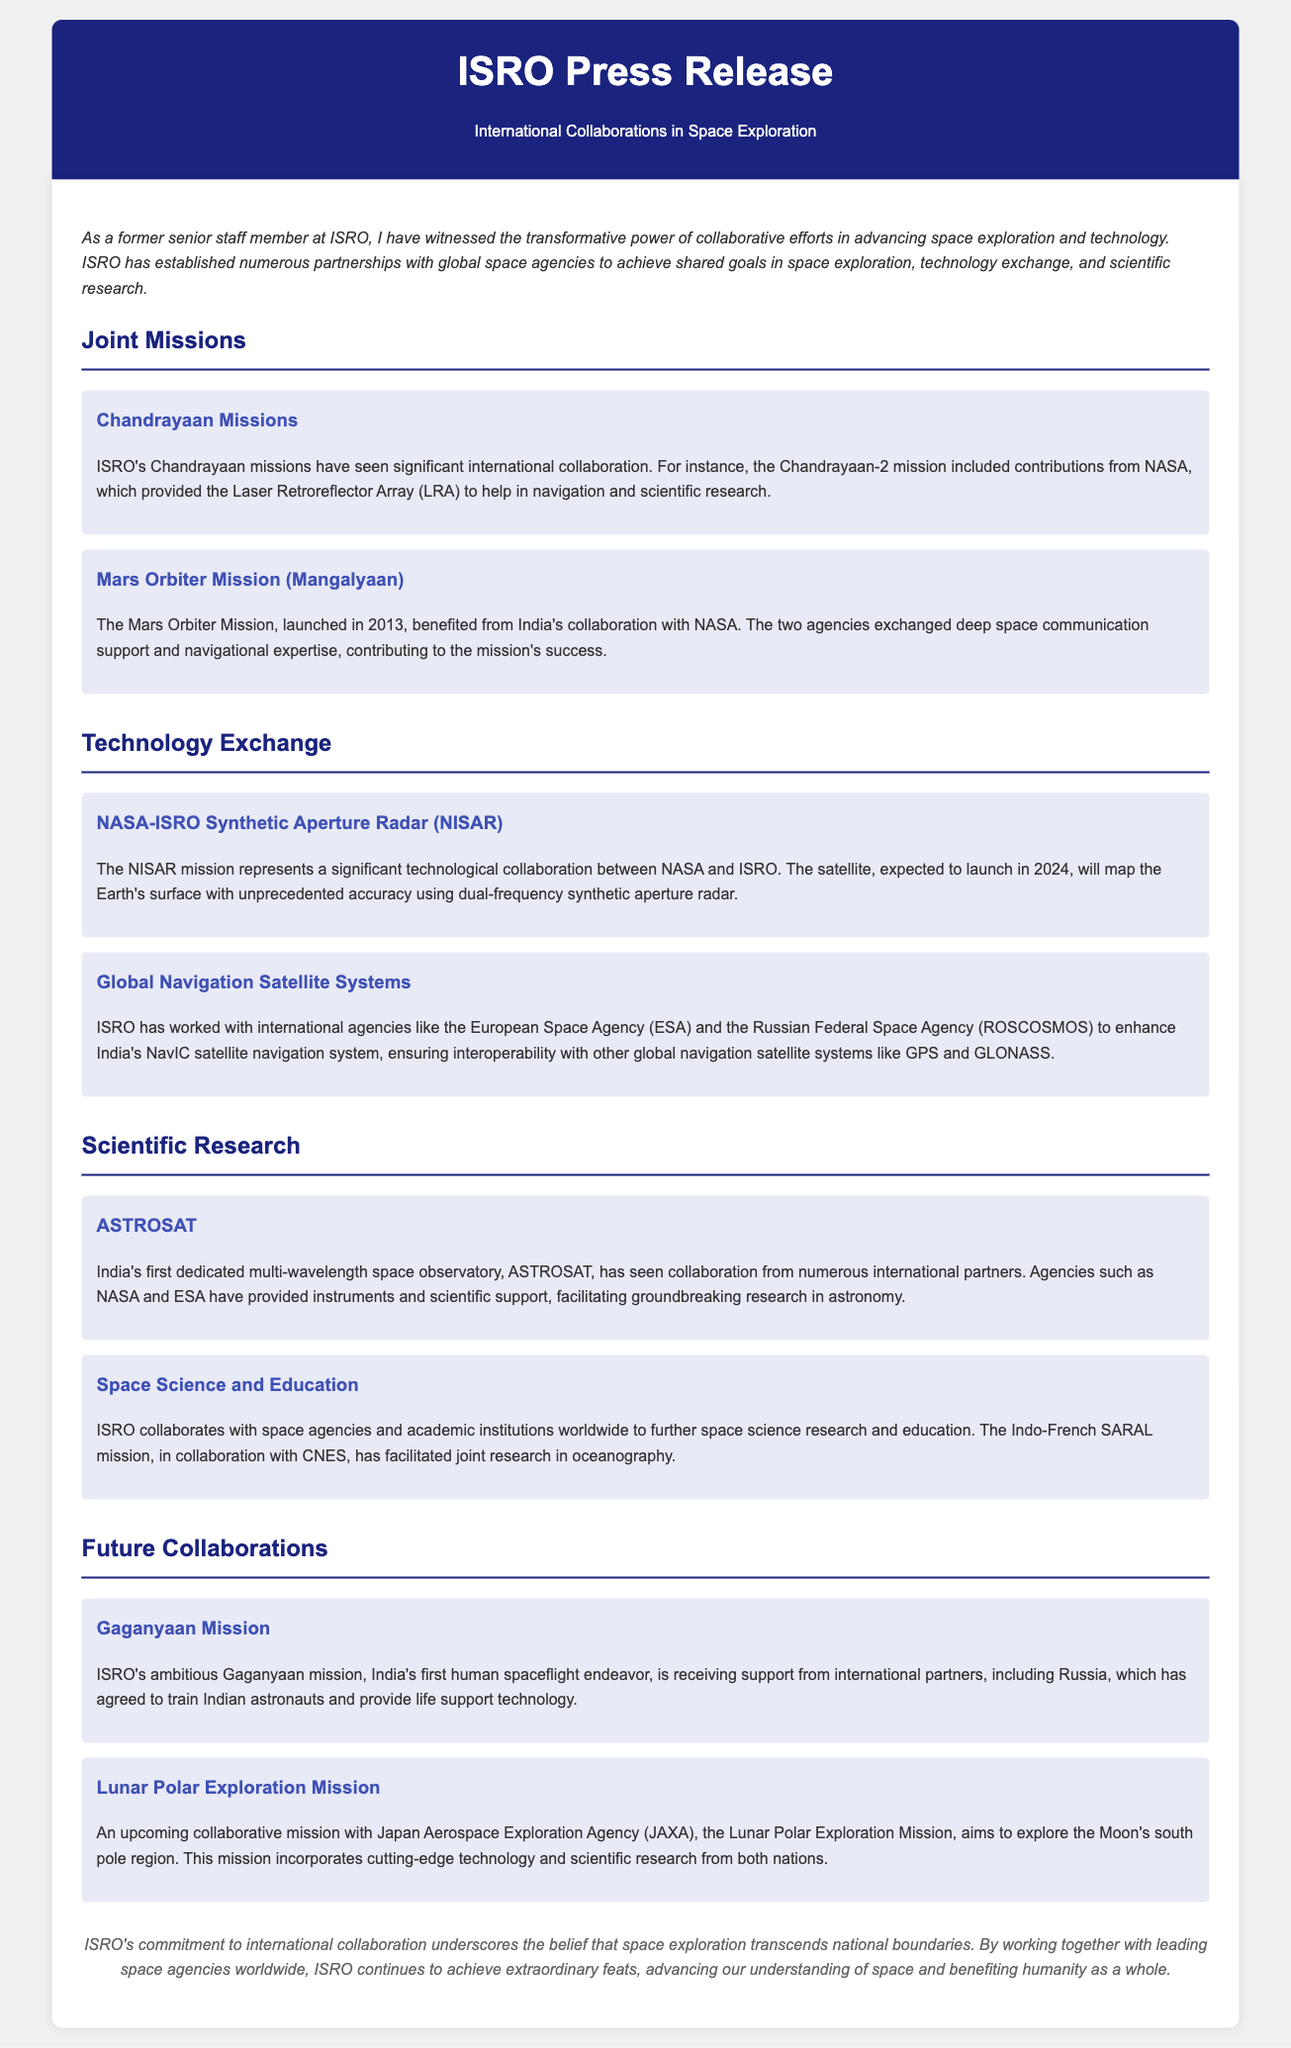what is the title of the press release? The title of the press release is found in the header section, stating the subject of the document.
Answer: International Collaborations in Space Exploration which agency provided the Laser Retroreflector Array for Chandrayaan-2? The information about the contributions to the Chandrayaan-2 mission specifies the agency that provided the LRA.
Answer: NASA in what year was the Mars Orbiter Mission launched? The document mentions the launch year of the Mars Orbiter Mission explicitly in relation to its partnership.
Answer: 2013 what is the expected launch year for the NISAR mission? The expected launch year for the NISAR mission is noted, indicating the timeline of the collaboration.
Answer: 2024 which mission is India's first human spaceflight endeavor? The document refers to a specific mission as India’s initial attempt at human spaceflight.
Answer: Gaganyaan name one of the international partners in the ASTROSAT mission. The ASTROSAT mission is highlighted for its international cooperation, and specific partner organizations are mentioned.
Answer: NASA what type of research is facilitated by the Indo-French SARAL mission? The document highlights the research focus of the Indo-French SARAL mission explicitly.
Answer: oceanography which agency is collaborating with ISRO on the Lunar Polar Exploration Mission? The document indicates the collaboration for the Lunar Polar Exploration Mission, naming the respective agency.
Answer: JAXA how does ISRO view its commitment to international collaboration in the conclusion? The conclusion expresses a particular sentiment regarding ISRO's philosophy towards international partnerships.
Answer: transcends national boundaries 